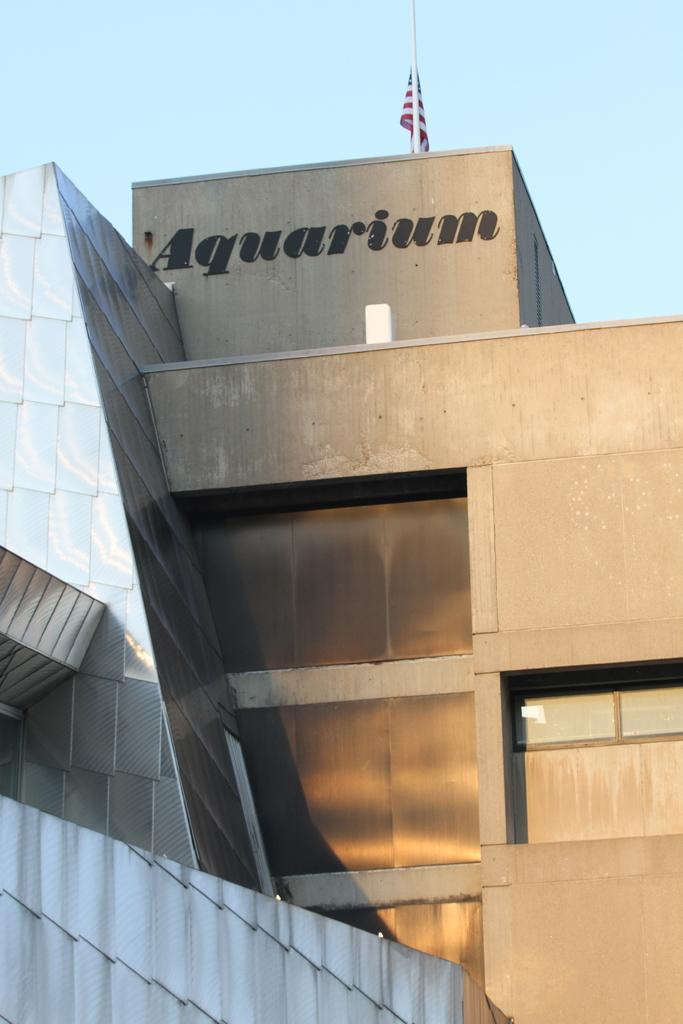<image>
Present a compact description of the photo's key features. Building with a flag on it and the word "Aquarium". 